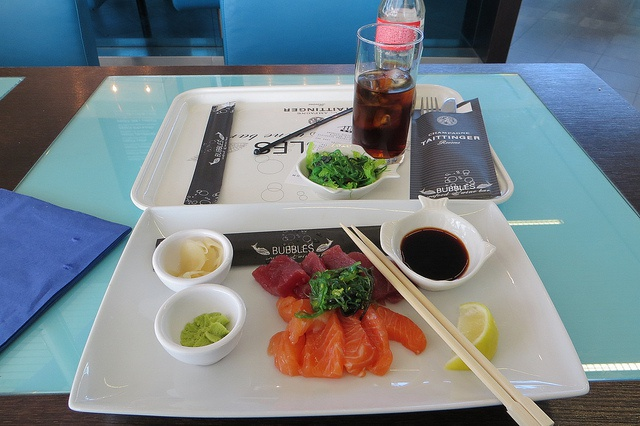Describe the objects in this image and their specific colors. I can see dining table in darkgray, gray, lightblue, lightgray, and black tones, chair in gray, teal, and blue tones, cup in gray, black, maroon, and darkgray tones, bowl in gray, black, darkgray, and lightgray tones, and chair in gray, teal, blue, and darkblue tones in this image. 